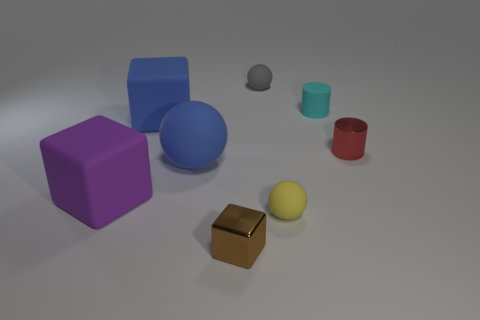There is a red metal cylinder; what number of large cubes are behind it?
Offer a very short reply. 1. What is the size of the metal thing in front of the matte ball on the left side of the metal block on the left side of the tiny yellow rubber thing?
Make the answer very short. Small. Is there a tiny cyan rubber cylinder that is left of the large matte block left of the cube that is behind the purple cube?
Offer a terse response. No. Is the number of red objects greater than the number of large yellow metallic objects?
Ensure brevity in your answer.  Yes. There is a small shiny thing that is to the right of the brown metal block; what color is it?
Offer a terse response. Red. Is the number of purple rubber cubes that are behind the purple object greater than the number of small cyan matte cylinders?
Your answer should be compact. No. Does the tiny yellow ball have the same material as the blue block?
Give a very brief answer. Yes. How many other things are the same shape as the red shiny object?
Make the answer very short. 1. Is there any other thing that has the same material as the yellow thing?
Offer a very short reply. Yes. The object in front of the small sphere in front of the tiny sphere behind the tiny red cylinder is what color?
Offer a terse response. Brown. 